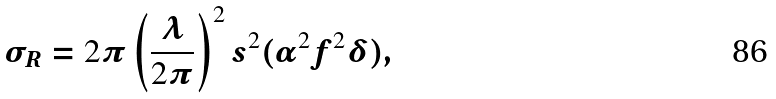<formula> <loc_0><loc_0><loc_500><loc_500>\sigma _ { R } = 2 \pi \left ( \frac { \lambda } { 2 \pi } \right ) ^ { 2 } s ^ { 2 } ( \alpha ^ { 2 } f ^ { 2 } \delta ) ,</formula> 